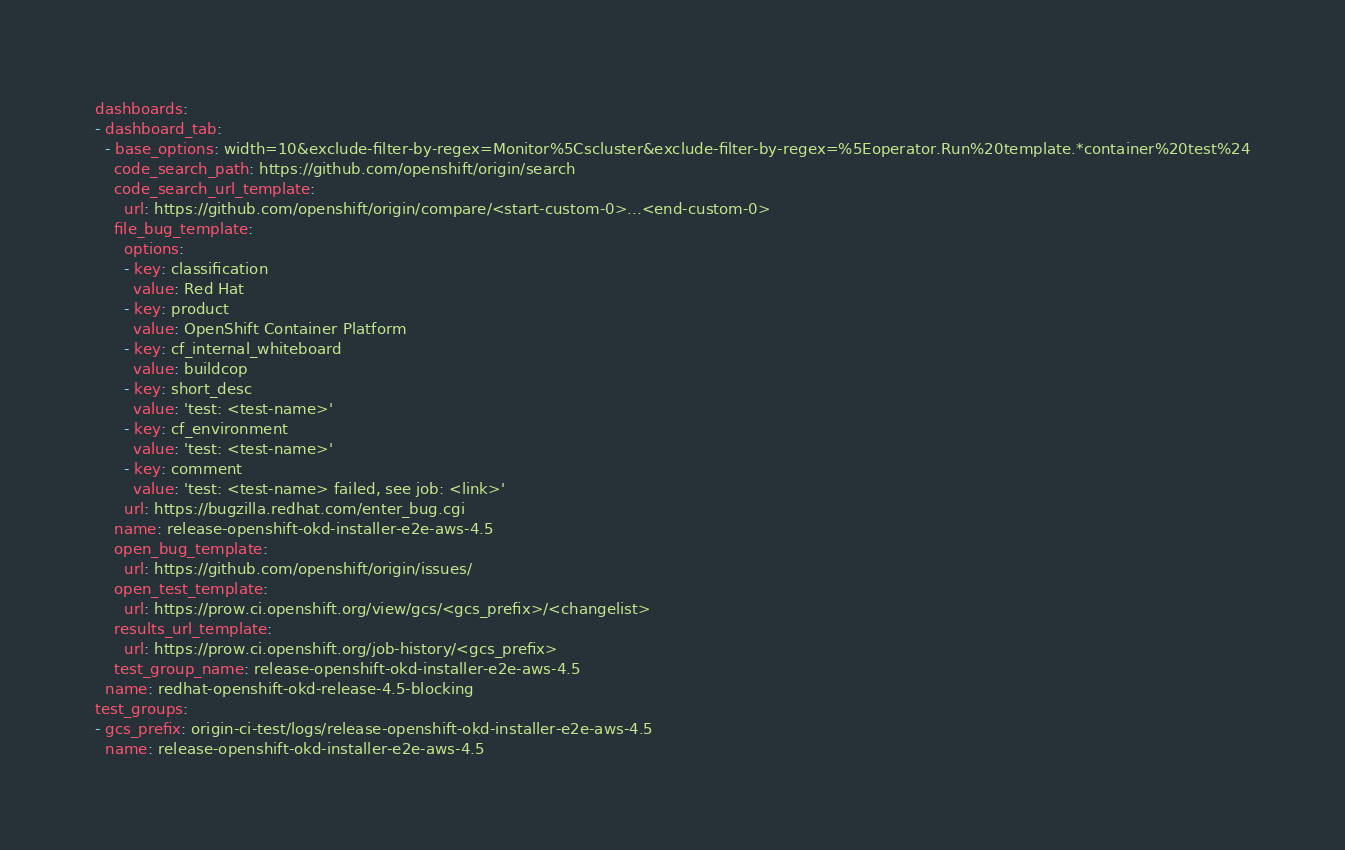<code> <loc_0><loc_0><loc_500><loc_500><_YAML_>dashboards:
- dashboard_tab:
  - base_options: width=10&exclude-filter-by-regex=Monitor%5Cscluster&exclude-filter-by-regex=%5Eoperator.Run%20template.*container%20test%24
    code_search_path: https://github.com/openshift/origin/search
    code_search_url_template:
      url: https://github.com/openshift/origin/compare/<start-custom-0>...<end-custom-0>
    file_bug_template:
      options:
      - key: classification
        value: Red Hat
      - key: product
        value: OpenShift Container Platform
      - key: cf_internal_whiteboard
        value: buildcop
      - key: short_desc
        value: 'test: <test-name>'
      - key: cf_environment
        value: 'test: <test-name>'
      - key: comment
        value: 'test: <test-name> failed, see job: <link>'
      url: https://bugzilla.redhat.com/enter_bug.cgi
    name: release-openshift-okd-installer-e2e-aws-4.5
    open_bug_template:
      url: https://github.com/openshift/origin/issues/
    open_test_template:
      url: https://prow.ci.openshift.org/view/gcs/<gcs_prefix>/<changelist>
    results_url_template:
      url: https://prow.ci.openshift.org/job-history/<gcs_prefix>
    test_group_name: release-openshift-okd-installer-e2e-aws-4.5
  name: redhat-openshift-okd-release-4.5-blocking
test_groups:
- gcs_prefix: origin-ci-test/logs/release-openshift-okd-installer-e2e-aws-4.5
  name: release-openshift-okd-installer-e2e-aws-4.5
</code> 